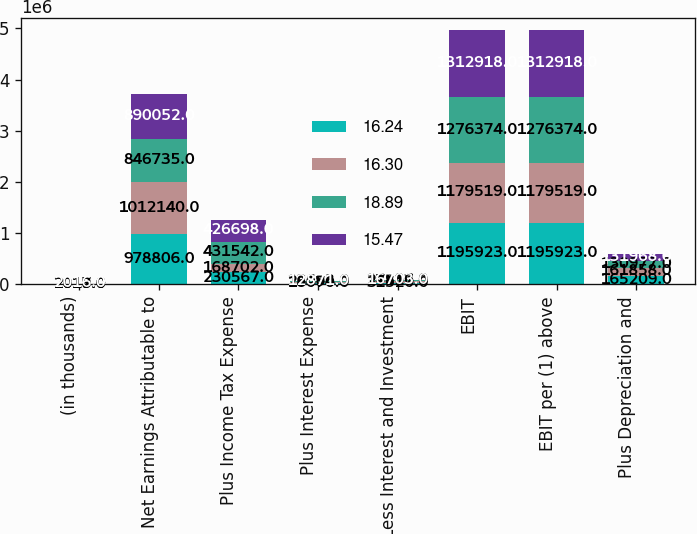<chart> <loc_0><loc_0><loc_500><loc_500><stacked_bar_chart><ecel><fcel>(in thousands)<fcel>Net Earnings Attributable to<fcel>Plus Income Tax Expense<fcel>Plus Interest Expense<fcel>Less Interest and Investment<fcel>EBIT<fcel>EBIT per (1) above<fcel>Plus Depreciation and<nl><fcel>16.24<fcel>2019<fcel>978806<fcel>230567<fcel>18070<fcel>31520<fcel>1.19592e+06<fcel>1.19592e+06<fcel>165209<nl><fcel>16.3<fcel>2018<fcel>1.01214e+06<fcel>168702<fcel>26494<fcel>27817<fcel>1.17952e+06<fcel>1.17952e+06<fcel>161858<nl><fcel>18.89<fcel>2017<fcel>846735<fcel>431542<fcel>12683<fcel>14586<fcel>1.27637e+06<fcel>1.27637e+06<fcel>130977<nl><fcel>15.47<fcel>2016<fcel>890052<fcel>426698<fcel>12871<fcel>16703<fcel>1.31292e+06<fcel>1.31292e+06<fcel>131968<nl></chart> 